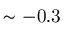Convert formula to latex. <formula><loc_0><loc_0><loc_500><loc_500>\sim - 0 . 3</formula> 